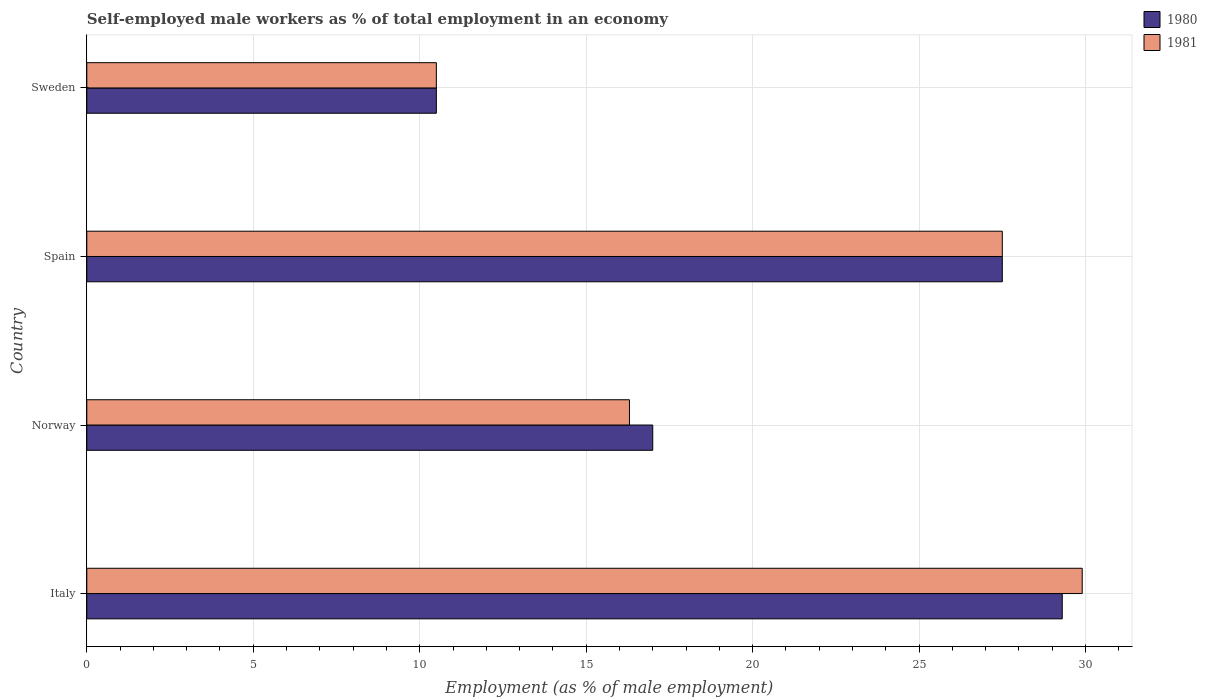How many different coloured bars are there?
Provide a succinct answer. 2. Are the number of bars per tick equal to the number of legend labels?
Offer a terse response. Yes. How many bars are there on the 4th tick from the top?
Make the answer very short. 2. How many bars are there on the 4th tick from the bottom?
Your answer should be very brief. 2. What is the label of the 1st group of bars from the top?
Your answer should be compact. Sweden. In how many cases, is the number of bars for a given country not equal to the number of legend labels?
Give a very brief answer. 0. What is the percentage of self-employed male workers in 1981 in Norway?
Give a very brief answer. 16.3. Across all countries, what is the maximum percentage of self-employed male workers in 1981?
Keep it short and to the point. 29.9. Across all countries, what is the minimum percentage of self-employed male workers in 1981?
Keep it short and to the point. 10.5. In which country was the percentage of self-employed male workers in 1981 maximum?
Give a very brief answer. Italy. In which country was the percentage of self-employed male workers in 1980 minimum?
Offer a very short reply. Sweden. What is the total percentage of self-employed male workers in 1980 in the graph?
Offer a very short reply. 84.3. What is the average percentage of self-employed male workers in 1980 per country?
Ensure brevity in your answer.  21.07. What is the difference between the percentage of self-employed male workers in 1981 and percentage of self-employed male workers in 1980 in Italy?
Provide a succinct answer. 0.6. What is the ratio of the percentage of self-employed male workers in 1980 in Norway to that in Spain?
Provide a short and direct response. 0.62. What is the difference between the highest and the second highest percentage of self-employed male workers in 1981?
Provide a short and direct response. 2.4. What is the difference between the highest and the lowest percentage of self-employed male workers in 1980?
Make the answer very short. 18.8. In how many countries, is the percentage of self-employed male workers in 1981 greater than the average percentage of self-employed male workers in 1981 taken over all countries?
Your answer should be compact. 2. Is the sum of the percentage of self-employed male workers in 1981 in Norway and Sweden greater than the maximum percentage of self-employed male workers in 1980 across all countries?
Your answer should be very brief. No. What does the 2nd bar from the top in Norway represents?
Offer a very short reply. 1980. How many bars are there?
Your answer should be compact. 8. Are all the bars in the graph horizontal?
Provide a short and direct response. Yes. How many countries are there in the graph?
Your answer should be very brief. 4. What is the difference between two consecutive major ticks on the X-axis?
Your answer should be compact. 5. Does the graph contain any zero values?
Your response must be concise. No. Does the graph contain grids?
Offer a terse response. Yes. How many legend labels are there?
Offer a terse response. 2. What is the title of the graph?
Your response must be concise. Self-employed male workers as % of total employment in an economy. What is the label or title of the X-axis?
Make the answer very short. Employment (as % of male employment). What is the Employment (as % of male employment) of 1980 in Italy?
Offer a very short reply. 29.3. What is the Employment (as % of male employment) of 1981 in Italy?
Make the answer very short. 29.9. What is the Employment (as % of male employment) of 1981 in Norway?
Offer a terse response. 16.3. What is the Employment (as % of male employment) in 1980 in Sweden?
Provide a succinct answer. 10.5. What is the Employment (as % of male employment) in 1981 in Sweden?
Give a very brief answer. 10.5. Across all countries, what is the maximum Employment (as % of male employment) in 1980?
Your response must be concise. 29.3. Across all countries, what is the maximum Employment (as % of male employment) in 1981?
Offer a very short reply. 29.9. Across all countries, what is the minimum Employment (as % of male employment) of 1980?
Your response must be concise. 10.5. What is the total Employment (as % of male employment) of 1980 in the graph?
Provide a short and direct response. 84.3. What is the total Employment (as % of male employment) of 1981 in the graph?
Keep it short and to the point. 84.2. What is the difference between the Employment (as % of male employment) of 1980 in Italy and that in Norway?
Make the answer very short. 12.3. What is the difference between the Employment (as % of male employment) in 1981 in Italy and that in Norway?
Your answer should be very brief. 13.6. What is the difference between the Employment (as % of male employment) of 1980 in Italy and that in Spain?
Offer a terse response. 1.8. What is the difference between the Employment (as % of male employment) of 1981 in Italy and that in Sweden?
Give a very brief answer. 19.4. What is the difference between the Employment (as % of male employment) of 1980 in Norway and that in Spain?
Provide a short and direct response. -10.5. What is the difference between the Employment (as % of male employment) in 1980 in Norway and that in Sweden?
Ensure brevity in your answer.  6.5. What is the difference between the Employment (as % of male employment) of 1981 in Norway and that in Sweden?
Offer a terse response. 5.8. What is the difference between the Employment (as % of male employment) of 1980 in Spain and that in Sweden?
Your answer should be compact. 17. What is the difference between the Employment (as % of male employment) of 1980 in Italy and the Employment (as % of male employment) of 1981 in Spain?
Offer a terse response. 1.8. What is the difference between the Employment (as % of male employment) in 1980 in Italy and the Employment (as % of male employment) in 1981 in Sweden?
Keep it short and to the point. 18.8. What is the difference between the Employment (as % of male employment) of 1980 in Norway and the Employment (as % of male employment) of 1981 in Spain?
Ensure brevity in your answer.  -10.5. What is the difference between the Employment (as % of male employment) of 1980 in Spain and the Employment (as % of male employment) of 1981 in Sweden?
Ensure brevity in your answer.  17. What is the average Employment (as % of male employment) in 1980 per country?
Provide a short and direct response. 21.07. What is the average Employment (as % of male employment) of 1981 per country?
Offer a very short reply. 21.05. What is the ratio of the Employment (as % of male employment) in 1980 in Italy to that in Norway?
Provide a short and direct response. 1.72. What is the ratio of the Employment (as % of male employment) in 1981 in Italy to that in Norway?
Ensure brevity in your answer.  1.83. What is the ratio of the Employment (as % of male employment) in 1980 in Italy to that in Spain?
Keep it short and to the point. 1.07. What is the ratio of the Employment (as % of male employment) of 1981 in Italy to that in Spain?
Your response must be concise. 1.09. What is the ratio of the Employment (as % of male employment) of 1980 in Italy to that in Sweden?
Offer a terse response. 2.79. What is the ratio of the Employment (as % of male employment) of 1981 in Italy to that in Sweden?
Offer a terse response. 2.85. What is the ratio of the Employment (as % of male employment) of 1980 in Norway to that in Spain?
Provide a short and direct response. 0.62. What is the ratio of the Employment (as % of male employment) of 1981 in Norway to that in Spain?
Provide a short and direct response. 0.59. What is the ratio of the Employment (as % of male employment) in 1980 in Norway to that in Sweden?
Your answer should be compact. 1.62. What is the ratio of the Employment (as % of male employment) of 1981 in Norway to that in Sweden?
Your response must be concise. 1.55. What is the ratio of the Employment (as % of male employment) of 1980 in Spain to that in Sweden?
Keep it short and to the point. 2.62. What is the ratio of the Employment (as % of male employment) in 1981 in Spain to that in Sweden?
Your answer should be very brief. 2.62. 